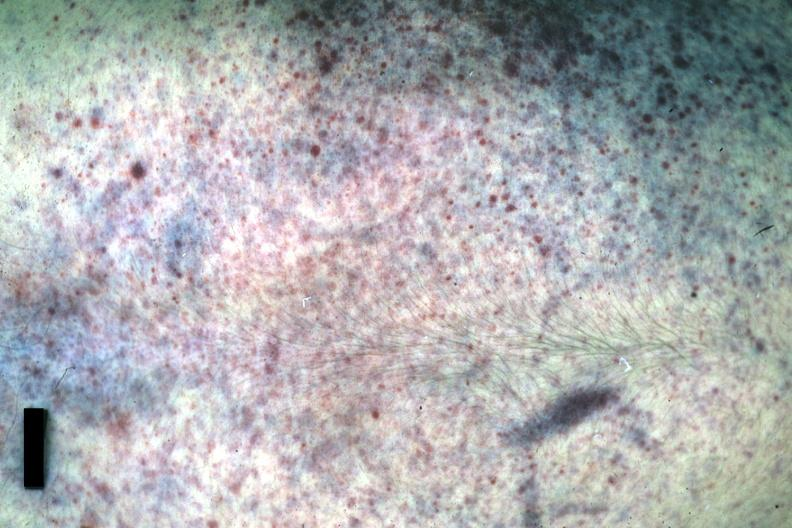where is this?
Answer the question using a single word or phrase. Skin 